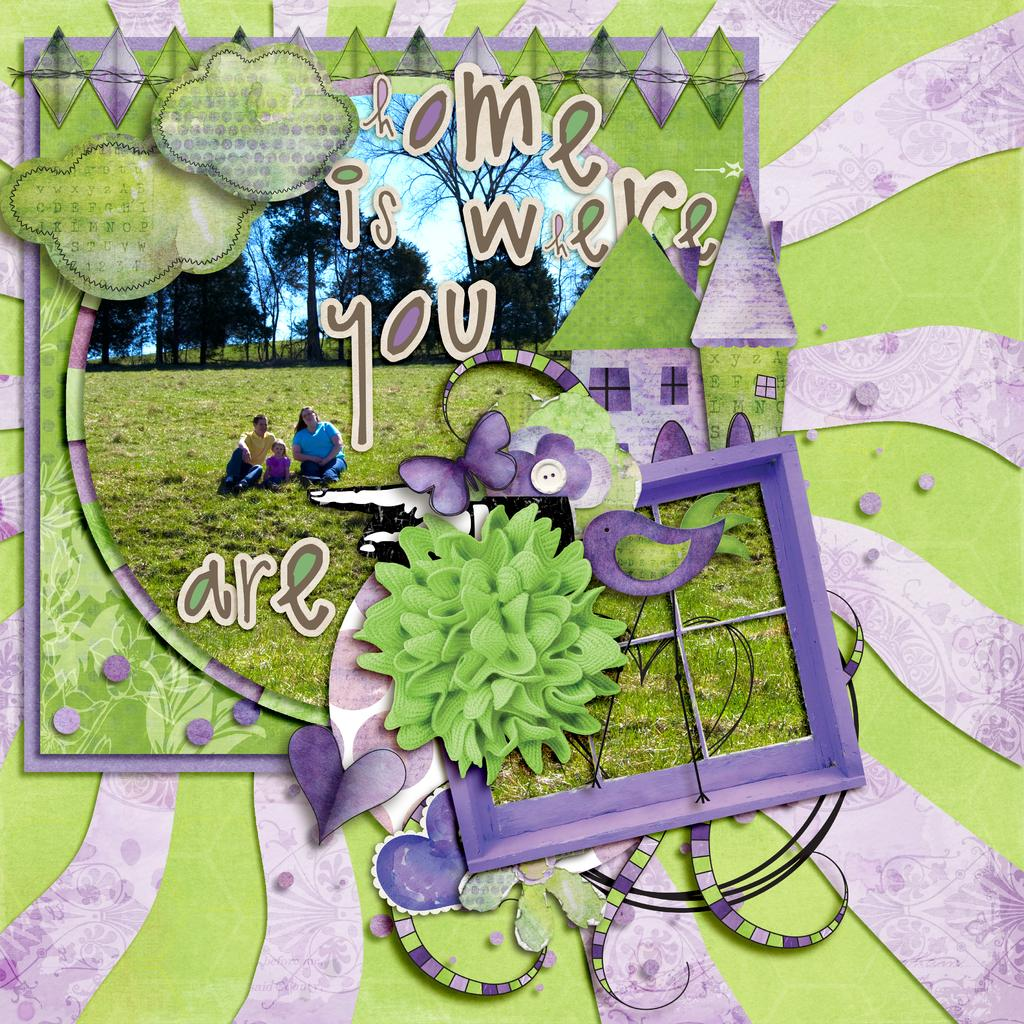What object is the main focus of the picture? There is a greeting card in the picture. What can be seen on the surface of the greeting card? The greeting card has a picture on it. Is there any text on the greeting card? Yes, there is writing on the greeting card. What type of bait is used to catch fish in the image? There is no bait or fishing activity present in the image; it features a greeting card with a picture and writing. What flavor of ice cream is depicted on the greeting card? The greeting card does not depict any ice cream; it has a picture and writing on it. 